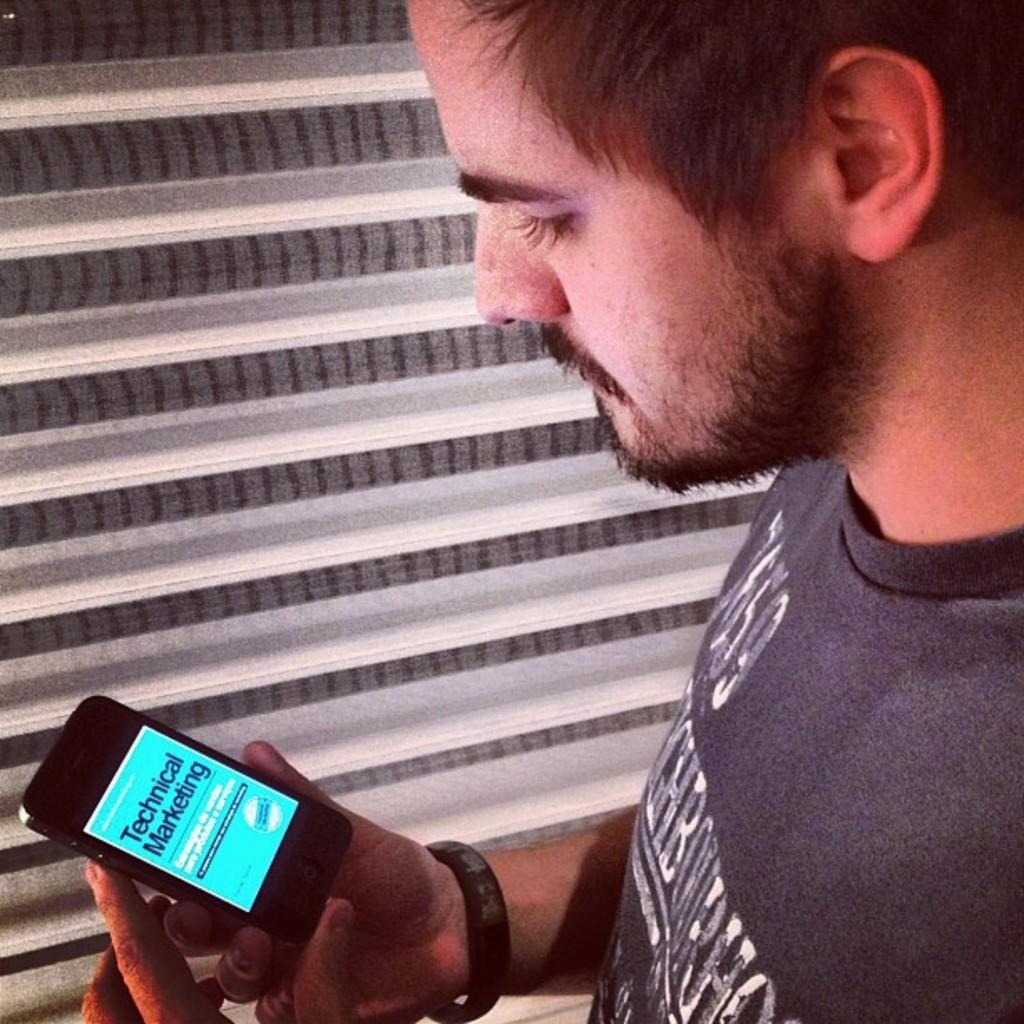Who is present in the image? There is a man in the image. What is the man holding in his hand? The man is holding a mobile in his hand. What accessory is the man wearing on his hand? The man is wearing a wristband on his hand. What type of eggnog is the man drinking in the image? There is no eggnog present in the image; the man is holding a mobile and wearing a wristband. 